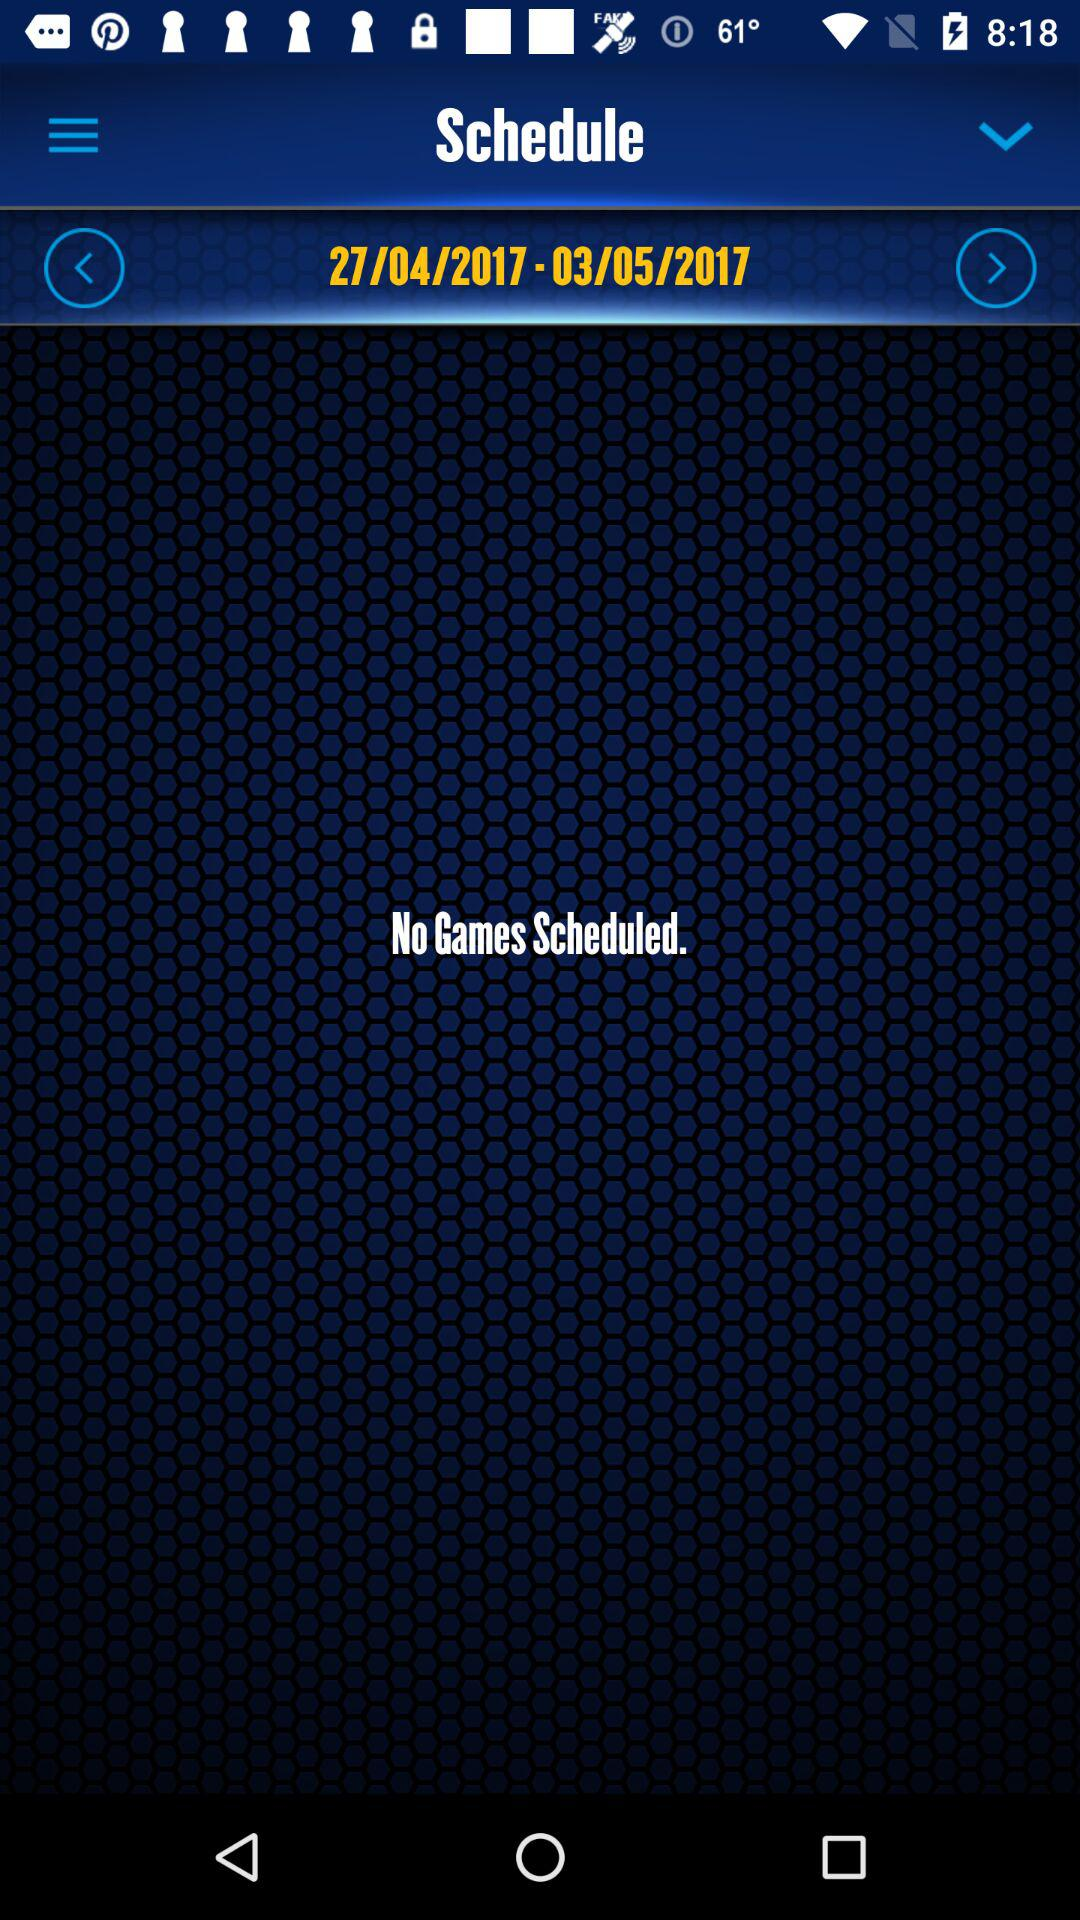Which date range is displayed? The displayed date range is from April 27, 2017 to May 3, 2017. 